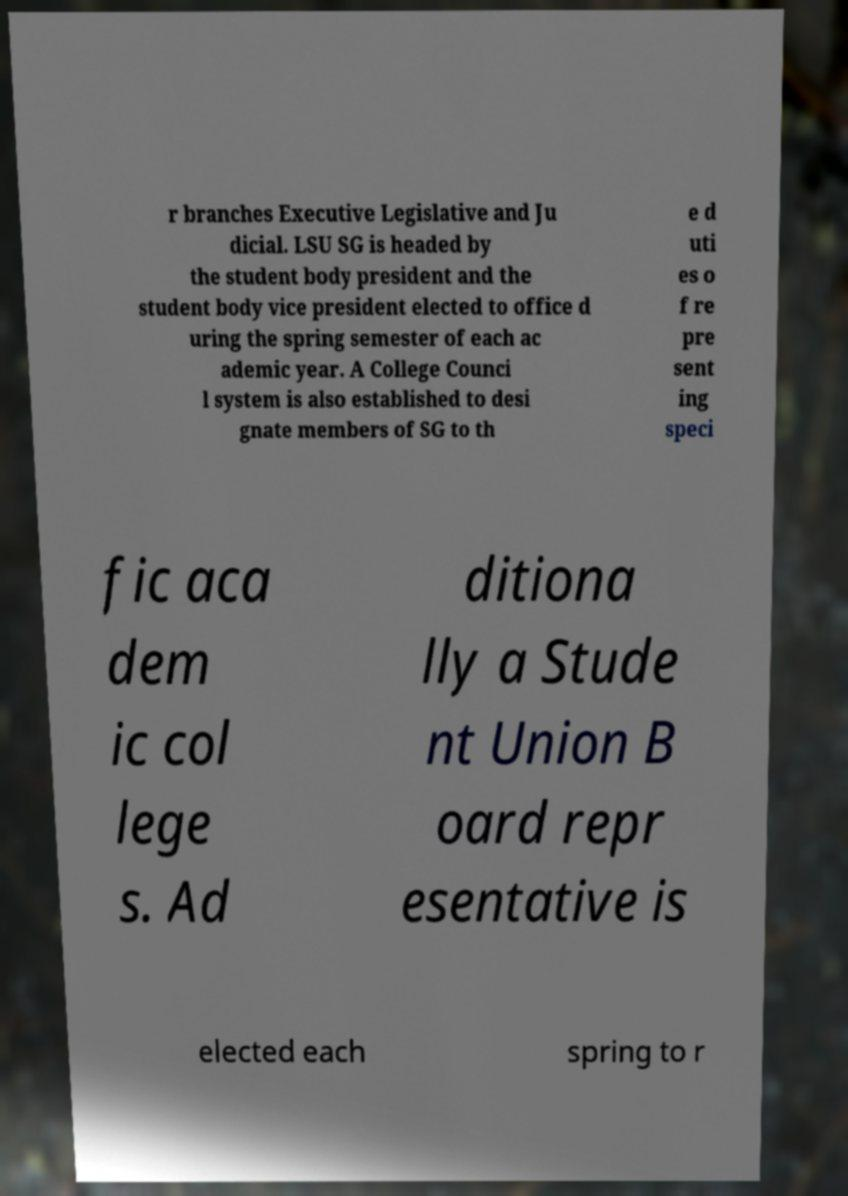I need the written content from this picture converted into text. Can you do that? r branches Executive Legislative and Ju dicial. LSU SG is headed by the student body president and the student body vice president elected to office d uring the spring semester of each ac ademic year. A College Counci l system is also established to desi gnate members of SG to th e d uti es o f re pre sent ing speci fic aca dem ic col lege s. Ad ditiona lly a Stude nt Union B oard repr esentative is elected each spring to r 